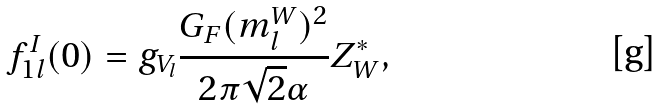<formula> <loc_0><loc_0><loc_500><loc_500>f _ { 1 l } ^ { I } ( 0 ) = g _ { V _ { l } } \frac { G _ { F } ( m _ { l } ^ { W } ) ^ { 2 } } { 2 \pi \sqrt { 2 } \alpha } Z _ { W } ^ { * } ,</formula> 